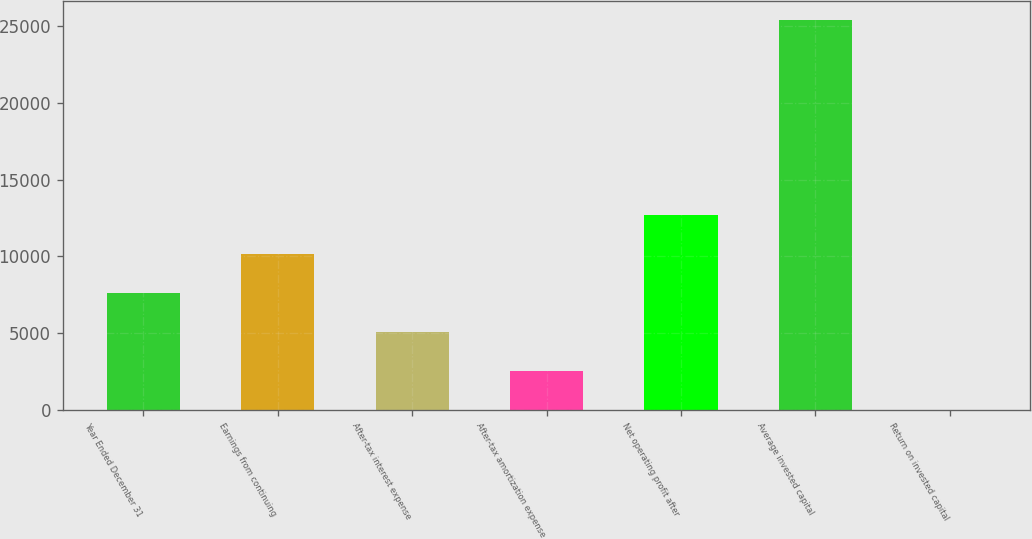Convert chart to OTSL. <chart><loc_0><loc_0><loc_500><loc_500><bar_chart><fcel>Year Ended December 31<fcel>Earnings from continuing<fcel>After-tax interest expense<fcel>After-tax amortization expense<fcel>Net operating profit after<fcel>Average invested capital<fcel>Return on invested capital<nl><fcel>7620.74<fcel>10155.9<fcel>5085.56<fcel>2550.38<fcel>12691.1<fcel>25367<fcel>15.2<nl></chart> 